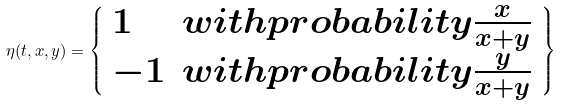Convert formula to latex. <formula><loc_0><loc_0><loc_500><loc_500>\eta ( t , x , y ) = \left \{ \begin{array} { l l } 1 & w i t h p r o b a b i l i t y \frac { x } { x + y } \\ - 1 & w i t h p r o b a b i l i t y \frac { y } { x + y } \end{array} \right \}</formula> 